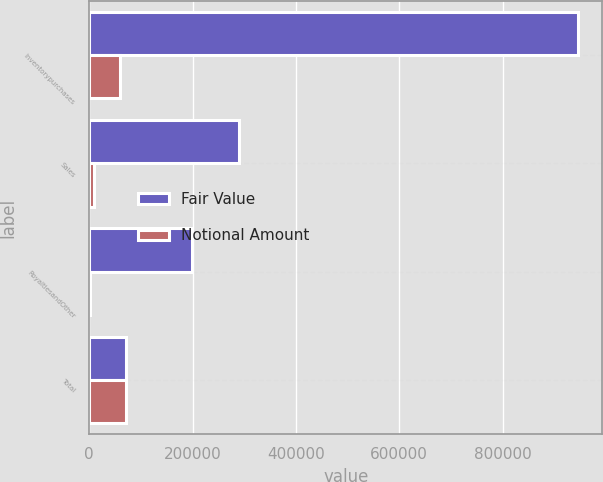<chart> <loc_0><loc_0><loc_500><loc_500><stacked_bar_chart><ecel><fcel>Inventorypurchases<fcel>Sales<fcel>RoyaltiesandOther<fcel>Total<nl><fcel>Fair Value<fcel>945728<fcel>290181<fcel>198849<fcel>71928<nl><fcel>Notional Amount<fcel>60520<fcel>9775<fcel>1633<fcel>71928<nl></chart> 